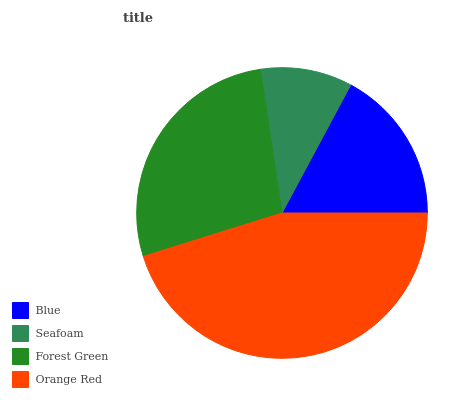Is Seafoam the minimum?
Answer yes or no. Yes. Is Orange Red the maximum?
Answer yes or no. Yes. Is Forest Green the minimum?
Answer yes or no. No. Is Forest Green the maximum?
Answer yes or no. No. Is Forest Green greater than Seafoam?
Answer yes or no. Yes. Is Seafoam less than Forest Green?
Answer yes or no. Yes. Is Seafoam greater than Forest Green?
Answer yes or no. No. Is Forest Green less than Seafoam?
Answer yes or no. No. Is Forest Green the high median?
Answer yes or no. Yes. Is Blue the low median?
Answer yes or no. Yes. Is Blue the high median?
Answer yes or no. No. Is Seafoam the low median?
Answer yes or no. No. 